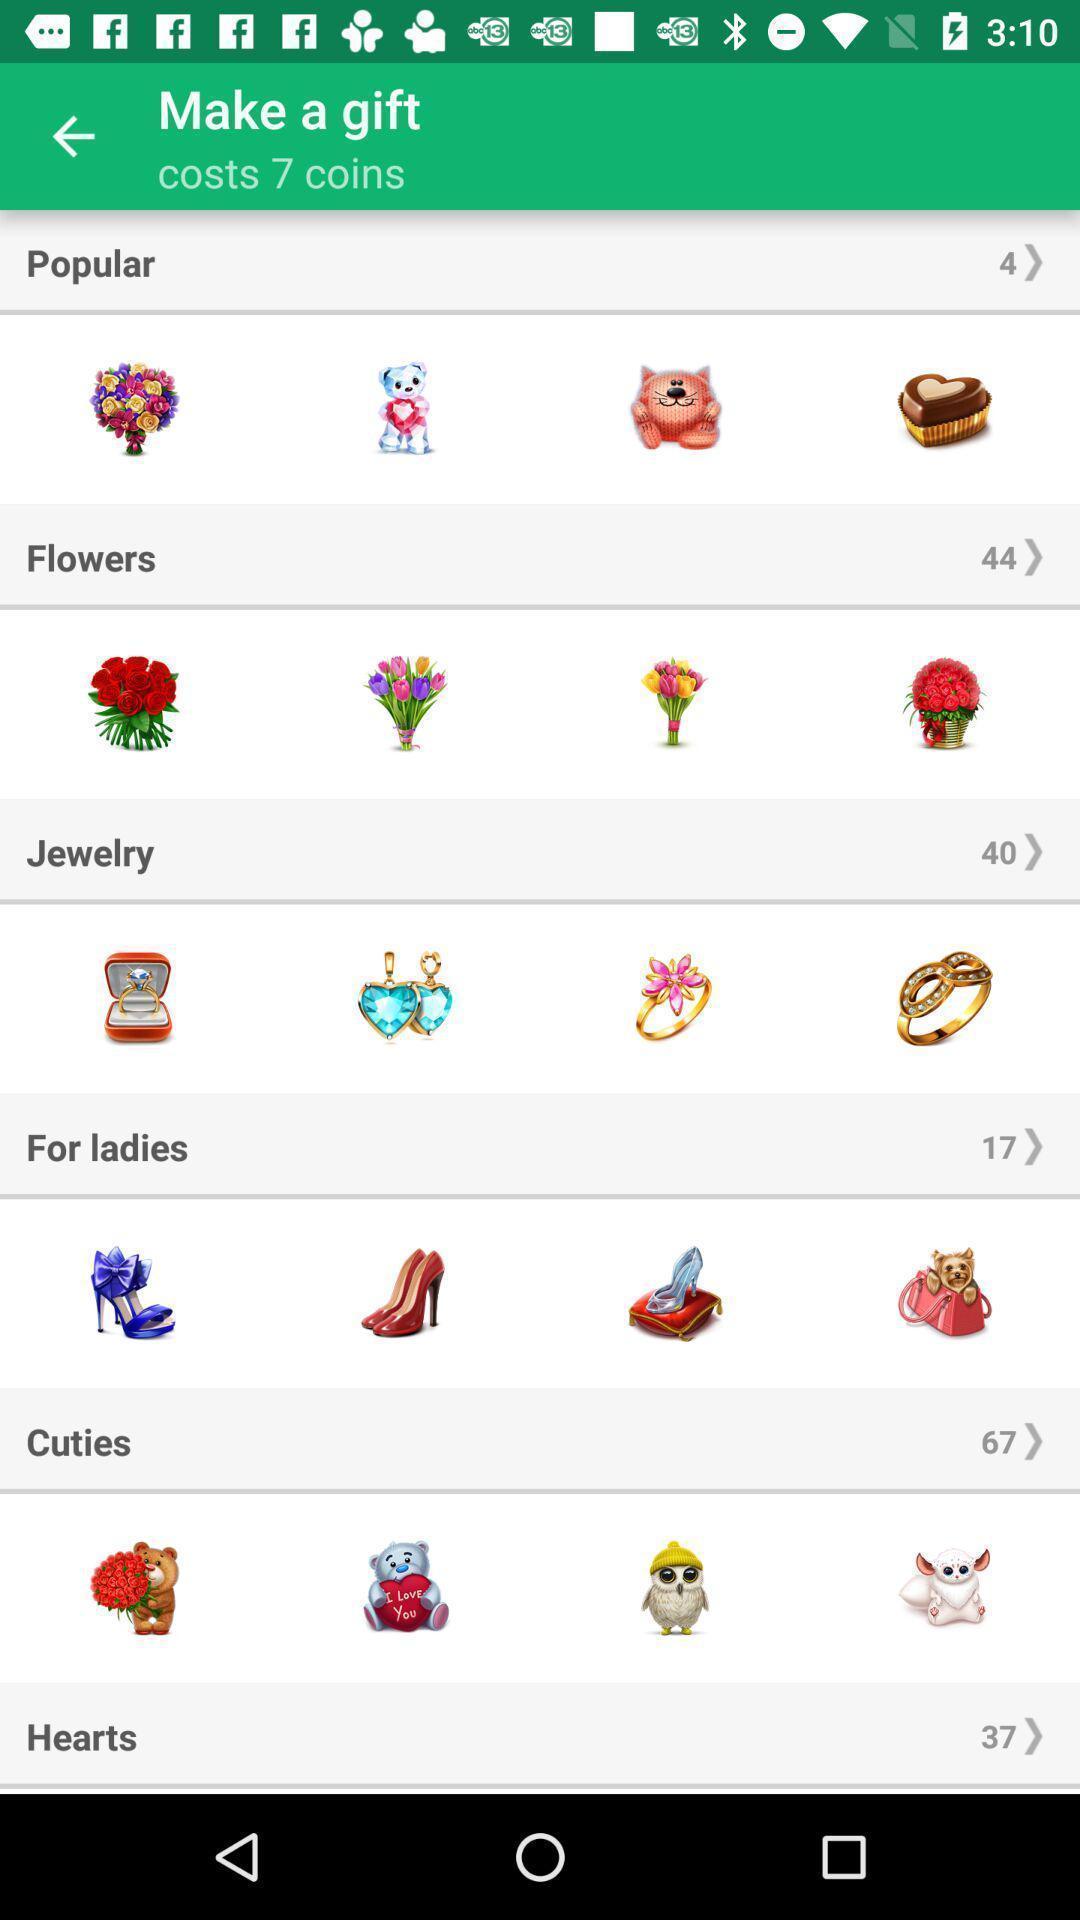Provide a textual representation of this image. Screen shows multiple options in a shopping application. 